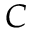Convert formula to latex. <formula><loc_0><loc_0><loc_500><loc_500>C</formula> 